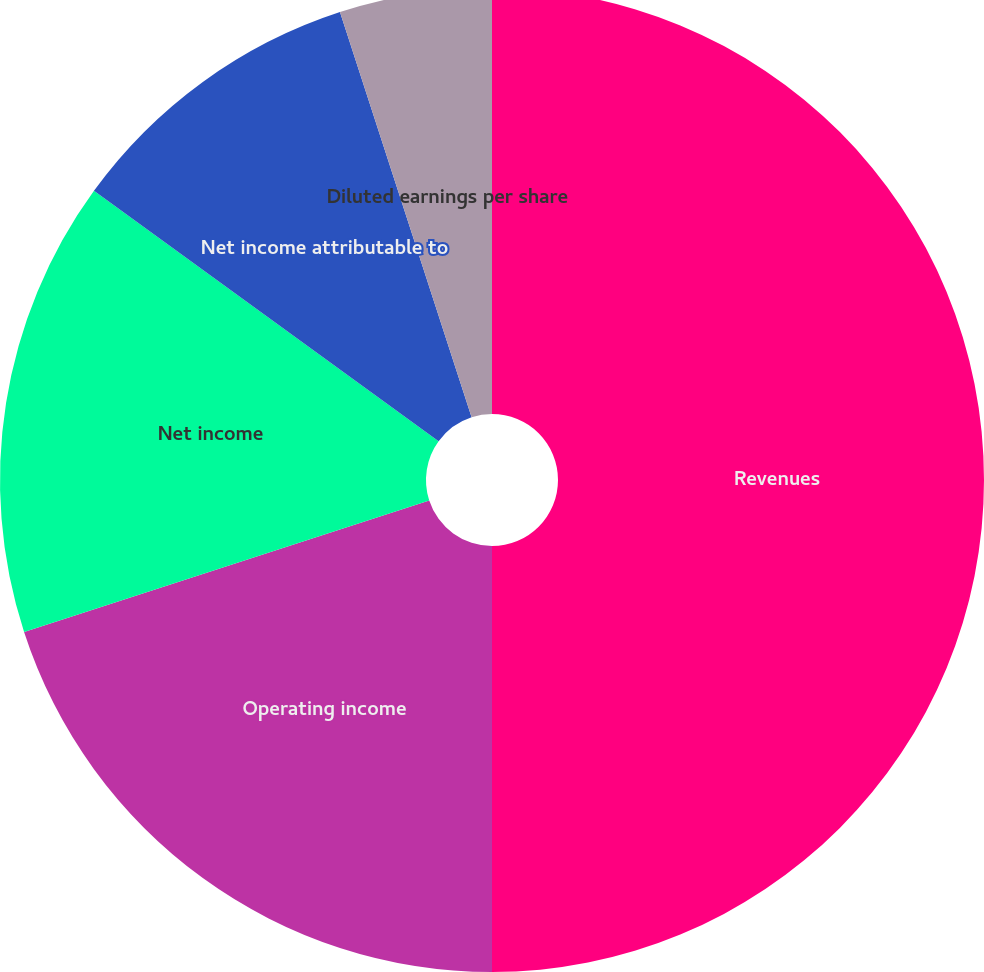Convert chart. <chart><loc_0><loc_0><loc_500><loc_500><pie_chart><fcel>Revenues<fcel>Operating income<fcel>Net income<fcel>Net income attributable to<fcel>Basic earnings per share<fcel>Diluted earnings per share<nl><fcel>50.0%<fcel>20.0%<fcel>15.0%<fcel>10.0%<fcel>0.0%<fcel>5.0%<nl></chart> 